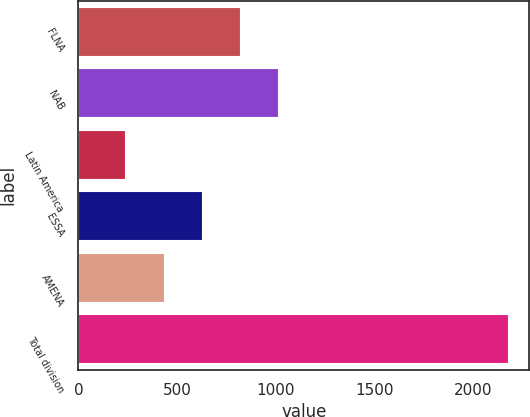<chart> <loc_0><loc_0><loc_500><loc_500><bar_chart><fcel>FLNA<fcel>NAB<fcel>Latin America<fcel>ESSA<fcel>AMENA<fcel>Total division<nl><fcel>819.1<fcel>1012.8<fcel>238<fcel>625.4<fcel>431.7<fcel>2175<nl></chart> 